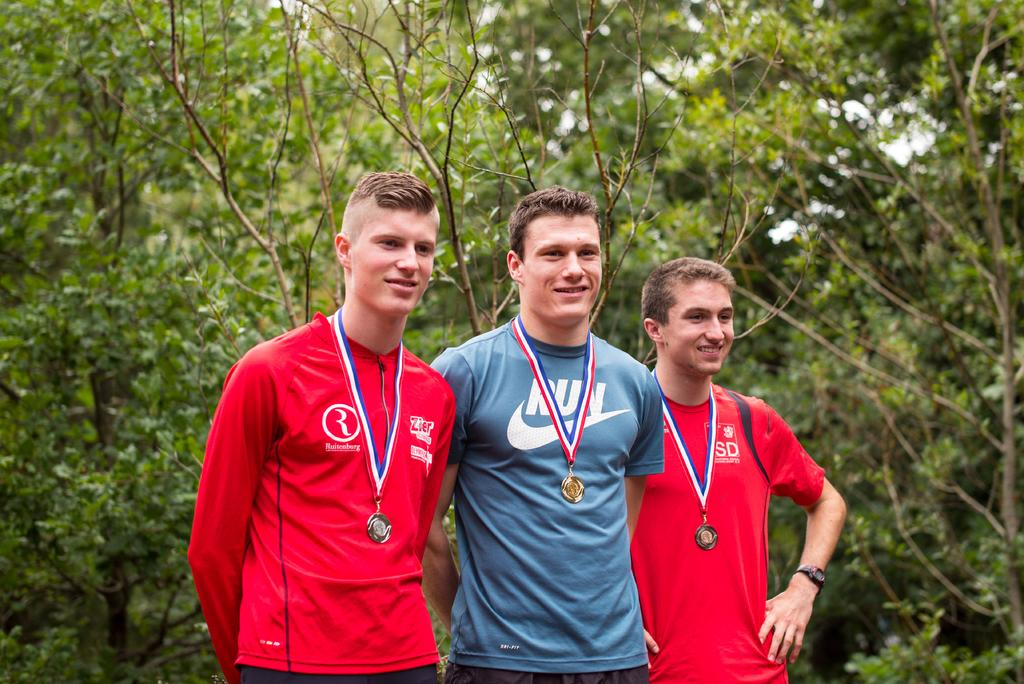What is located in the middle of the image? There are people standing in the middle of the image. What expression do the people have in the image? The people are smiling. What can be seen in the background of the image? There are trees in the background of the image. What type of magic is being performed by the people in the image? There is no indication of magic or any magical activity in the image. Can you tell me how many birds are in the flock flying above the people in the image? There is no flock of birds or any birds visible in the image. 